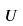Convert formula to latex. <formula><loc_0><loc_0><loc_500><loc_500>U</formula> 